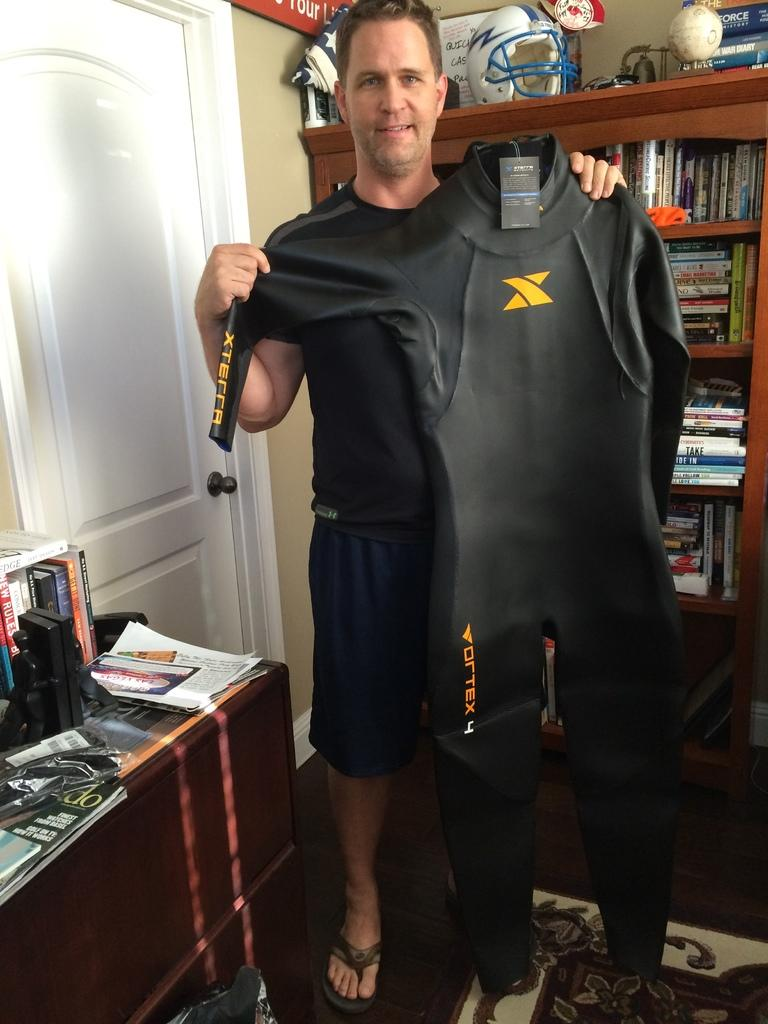<image>
Relay a brief, clear account of the picture shown. Man holding a black suit that says Vortex near the bottom. 